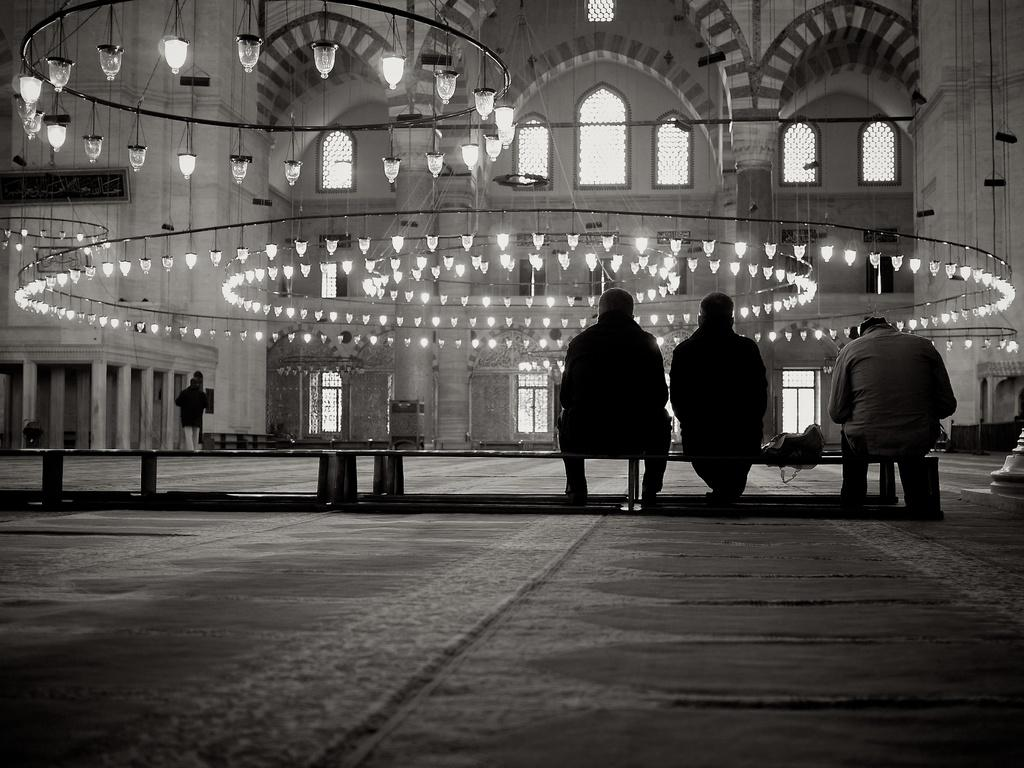What is the color scheme of the image? The image is black and white. How many people are sitting on the bench in the image? There are three people sitting on a bench in the image. What is located in front of the people? There is a building and decorative lights in front of the people. What type of wrench is being used to adjust the pump in the image? There is no wrench or pump present in the image. What punishment is being administered to the people sitting on the bench in the image? There is no punishment being administered to the people sitting on the bench in the image. 